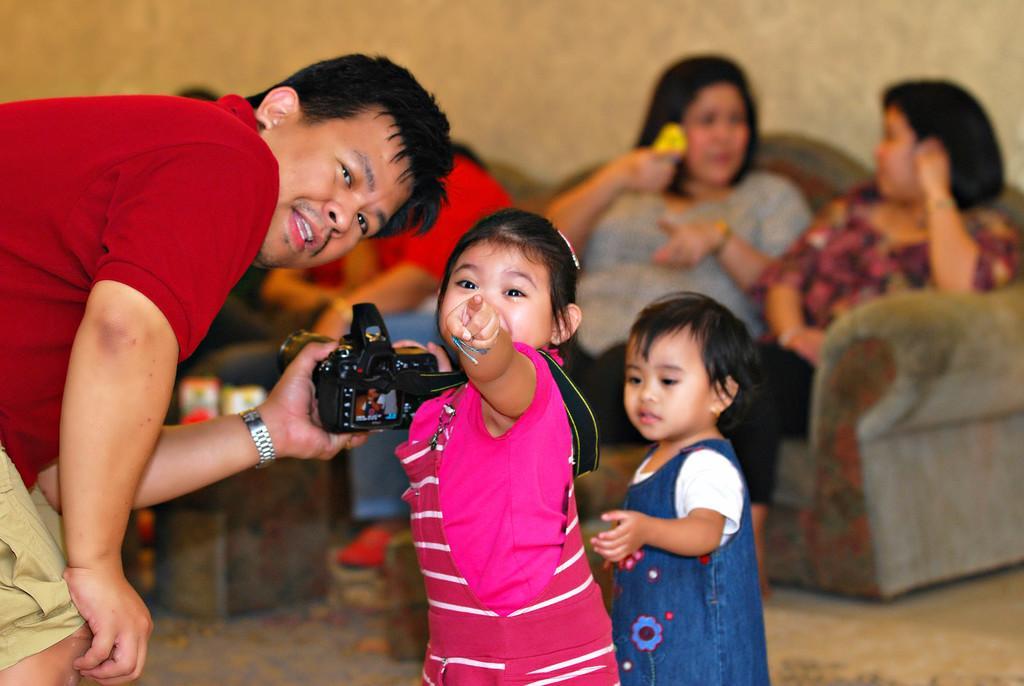In one or two sentences, can you explain what this image depicts? In this picture there is a man wearing a red t shirt, holding a camera in his hands. There are two kids standing beside him. In the background there are three women sitting in the sofa. We can observe a wall here. 